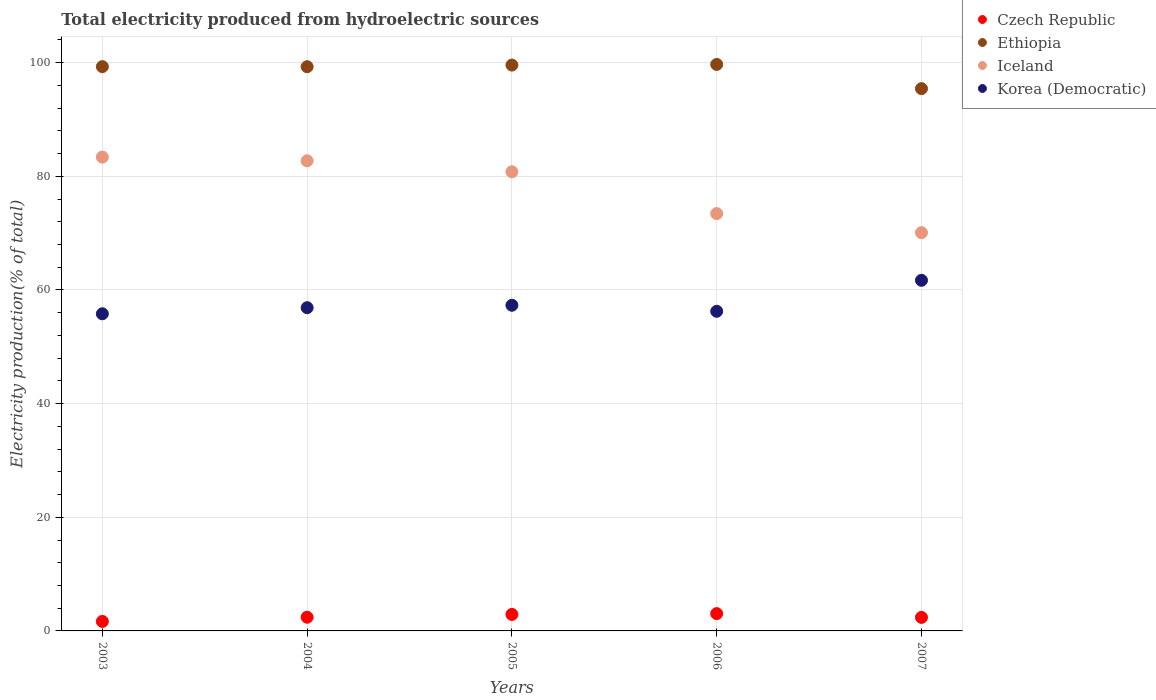How many different coloured dotlines are there?
Give a very brief answer. 4. What is the total electricity produced in Korea (Democratic) in 2003?
Your answer should be compact. 55.81. Across all years, what is the maximum total electricity produced in Czech Republic?
Offer a very short reply. 3.05. Across all years, what is the minimum total electricity produced in Iceland?
Ensure brevity in your answer.  70.08. In which year was the total electricity produced in Iceland maximum?
Offer a terse response. 2003. What is the total total electricity produced in Czech Republic in the graph?
Offer a terse response. 12.41. What is the difference between the total electricity produced in Ethiopia in 2003 and that in 2004?
Your answer should be very brief. 0.01. What is the difference between the total electricity produced in Ethiopia in 2006 and the total electricity produced in Czech Republic in 2007?
Your response must be concise. 97.31. What is the average total electricity produced in Iceland per year?
Provide a short and direct response. 78.09. In the year 2005, what is the difference between the total electricity produced in Iceland and total electricity produced in Korea (Democratic)?
Offer a very short reply. 23.5. What is the ratio of the total electricity produced in Korea (Democratic) in 2005 to that in 2007?
Offer a terse response. 0.93. What is the difference between the highest and the second highest total electricity produced in Iceland?
Give a very brief answer. 0.66. What is the difference between the highest and the lowest total electricity produced in Czech Republic?
Offer a terse response. 1.38. Is it the case that in every year, the sum of the total electricity produced in Ethiopia and total electricity produced in Korea (Democratic)  is greater than the total electricity produced in Czech Republic?
Your answer should be compact. Yes. Is the total electricity produced in Korea (Democratic) strictly less than the total electricity produced in Czech Republic over the years?
Ensure brevity in your answer.  No. How many dotlines are there?
Provide a succinct answer. 4. How many years are there in the graph?
Ensure brevity in your answer.  5. What is the difference between two consecutive major ticks on the Y-axis?
Provide a short and direct response. 20. Does the graph contain any zero values?
Make the answer very short. No. How many legend labels are there?
Ensure brevity in your answer.  4. How are the legend labels stacked?
Keep it short and to the point. Vertical. What is the title of the graph?
Offer a terse response. Total electricity produced from hydroelectric sources. Does "Macedonia" appear as one of the legend labels in the graph?
Your answer should be very brief. No. What is the Electricity production(% of total) in Czech Republic in 2003?
Give a very brief answer. 1.67. What is the Electricity production(% of total) in Ethiopia in 2003?
Make the answer very short. 99.3. What is the Electricity production(% of total) in Iceland in 2003?
Give a very brief answer. 83.39. What is the Electricity production(% of total) of Korea (Democratic) in 2003?
Your response must be concise. 55.81. What is the Electricity production(% of total) of Czech Republic in 2004?
Give a very brief answer. 2.41. What is the Electricity production(% of total) of Ethiopia in 2004?
Offer a terse response. 99.29. What is the Electricity production(% of total) in Iceland in 2004?
Your answer should be very brief. 82.73. What is the Electricity production(% of total) of Korea (Democratic) in 2004?
Provide a succinct answer. 56.89. What is the Electricity production(% of total) of Czech Republic in 2005?
Offer a very short reply. 2.9. What is the Electricity production(% of total) of Ethiopia in 2005?
Provide a short and direct response. 99.58. What is the Electricity production(% of total) of Iceland in 2005?
Keep it short and to the point. 80.81. What is the Electricity production(% of total) in Korea (Democratic) in 2005?
Keep it short and to the point. 57.31. What is the Electricity production(% of total) in Czech Republic in 2006?
Provide a short and direct response. 3.05. What is the Electricity production(% of total) in Ethiopia in 2006?
Offer a very short reply. 99.69. What is the Electricity production(% of total) in Iceland in 2006?
Your answer should be compact. 73.44. What is the Electricity production(% of total) in Korea (Democratic) in 2006?
Provide a succinct answer. 56.25. What is the Electricity production(% of total) of Czech Republic in 2007?
Provide a short and direct response. 2.38. What is the Electricity production(% of total) in Ethiopia in 2007?
Provide a short and direct response. 95.43. What is the Electricity production(% of total) in Iceland in 2007?
Your answer should be compact. 70.08. What is the Electricity production(% of total) in Korea (Democratic) in 2007?
Provide a short and direct response. 61.7. Across all years, what is the maximum Electricity production(% of total) of Czech Republic?
Offer a terse response. 3.05. Across all years, what is the maximum Electricity production(% of total) in Ethiopia?
Provide a succinct answer. 99.69. Across all years, what is the maximum Electricity production(% of total) in Iceland?
Provide a short and direct response. 83.39. Across all years, what is the maximum Electricity production(% of total) in Korea (Democratic)?
Your answer should be very brief. 61.7. Across all years, what is the minimum Electricity production(% of total) in Czech Republic?
Ensure brevity in your answer.  1.67. Across all years, what is the minimum Electricity production(% of total) of Ethiopia?
Offer a very short reply. 95.43. Across all years, what is the minimum Electricity production(% of total) in Iceland?
Your response must be concise. 70.08. Across all years, what is the minimum Electricity production(% of total) in Korea (Democratic)?
Provide a succinct answer. 55.81. What is the total Electricity production(% of total) in Czech Republic in the graph?
Your answer should be very brief. 12.41. What is the total Electricity production(% of total) of Ethiopia in the graph?
Offer a terse response. 493.3. What is the total Electricity production(% of total) of Iceland in the graph?
Your answer should be very brief. 390.46. What is the total Electricity production(% of total) of Korea (Democratic) in the graph?
Provide a succinct answer. 287.96. What is the difference between the Electricity production(% of total) in Czech Republic in 2003 and that in 2004?
Ensure brevity in your answer.  -0.74. What is the difference between the Electricity production(% of total) in Ethiopia in 2003 and that in 2004?
Offer a terse response. 0.01. What is the difference between the Electricity production(% of total) of Iceland in 2003 and that in 2004?
Your answer should be very brief. 0.66. What is the difference between the Electricity production(% of total) of Korea (Democratic) in 2003 and that in 2004?
Your answer should be compact. -1.07. What is the difference between the Electricity production(% of total) of Czech Republic in 2003 and that in 2005?
Your answer should be compact. -1.23. What is the difference between the Electricity production(% of total) of Ethiopia in 2003 and that in 2005?
Give a very brief answer. -0.28. What is the difference between the Electricity production(% of total) of Iceland in 2003 and that in 2005?
Your response must be concise. 2.58. What is the difference between the Electricity production(% of total) in Korea (Democratic) in 2003 and that in 2005?
Your answer should be compact. -1.5. What is the difference between the Electricity production(% of total) in Czech Republic in 2003 and that in 2006?
Your response must be concise. -1.38. What is the difference between the Electricity production(% of total) in Ethiopia in 2003 and that in 2006?
Provide a short and direct response. -0.39. What is the difference between the Electricity production(% of total) of Iceland in 2003 and that in 2006?
Your answer should be very brief. 9.94. What is the difference between the Electricity production(% of total) in Korea (Democratic) in 2003 and that in 2006?
Keep it short and to the point. -0.44. What is the difference between the Electricity production(% of total) in Czech Republic in 2003 and that in 2007?
Keep it short and to the point. -0.71. What is the difference between the Electricity production(% of total) in Ethiopia in 2003 and that in 2007?
Your answer should be compact. 3.87. What is the difference between the Electricity production(% of total) in Iceland in 2003 and that in 2007?
Ensure brevity in your answer.  13.3. What is the difference between the Electricity production(% of total) in Korea (Democratic) in 2003 and that in 2007?
Your answer should be very brief. -5.89. What is the difference between the Electricity production(% of total) of Czech Republic in 2004 and that in 2005?
Ensure brevity in your answer.  -0.5. What is the difference between the Electricity production(% of total) of Ethiopia in 2004 and that in 2005?
Your answer should be compact. -0.29. What is the difference between the Electricity production(% of total) of Iceland in 2004 and that in 2005?
Your response must be concise. 1.92. What is the difference between the Electricity production(% of total) in Korea (Democratic) in 2004 and that in 2005?
Ensure brevity in your answer.  -0.43. What is the difference between the Electricity production(% of total) in Czech Republic in 2004 and that in 2006?
Your answer should be very brief. -0.64. What is the difference between the Electricity production(% of total) in Ethiopia in 2004 and that in 2006?
Provide a succinct answer. -0.4. What is the difference between the Electricity production(% of total) of Iceland in 2004 and that in 2006?
Offer a terse response. 9.29. What is the difference between the Electricity production(% of total) of Korea (Democratic) in 2004 and that in 2006?
Offer a very short reply. 0.64. What is the difference between the Electricity production(% of total) of Czech Republic in 2004 and that in 2007?
Your response must be concise. 0.03. What is the difference between the Electricity production(% of total) of Ethiopia in 2004 and that in 2007?
Your answer should be very brief. 3.86. What is the difference between the Electricity production(% of total) in Iceland in 2004 and that in 2007?
Offer a terse response. 12.65. What is the difference between the Electricity production(% of total) in Korea (Democratic) in 2004 and that in 2007?
Make the answer very short. -4.82. What is the difference between the Electricity production(% of total) in Czech Republic in 2005 and that in 2006?
Make the answer very short. -0.14. What is the difference between the Electricity production(% of total) in Ethiopia in 2005 and that in 2006?
Provide a succinct answer. -0.12. What is the difference between the Electricity production(% of total) in Iceland in 2005 and that in 2006?
Your answer should be very brief. 7.36. What is the difference between the Electricity production(% of total) of Korea (Democratic) in 2005 and that in 2006?
Your response must be concise. 1.06. What is the difference between the Electricity production(% of total) of Czech Republic in 2005 and that in 2007?
Keep it short and to the point. 0.52. What is the difference between the Electricity production(% of total) of Ethiopia in 2005 and that in 2007?
Your answer should be very brief. 4.15. What is the difference between the Electricity production(% of total) of Iceland in 2005 and that in 2007?
Your response must be concise. 10.72. What is the difference between the Electricity production(% of total) in Korea (Democratic) in 2005 and that in 2007?
Your answer should be compact. -4.39. What is the difference between the Electricity production(% of total) of Czech Republic in 2006 and that in 2007?
Your response must be concise. 0.67. What is the difference between the Electricity production(% of total) of Ethiopia in 2006 and that in 2007?
Offer a very short reply. 4.26. What is the difference between the Electricity production(% of total) of Iceland in 2006 and that in 2007?
Offer a terse response. 3.36. What is the difference between the Electricity production(% of total) of Korea (Democratic) in 2006 and that in 2007?
Your answer should be compact. -5.45. What is the difference between the Electricity production(% of total) of Czech Republic in 2003 and the Electricity production(% of total) of Ethiopia in 2004?
Ensure brevity in your answer.  -97.62. What is the difference between the Electricity production(% of total) of Czech Republic in 2003 and the Electricity production(% of total) of Iceland in 2004?
Ensure brevity in your answer.  -81.06. What is the difference between the Electricity production(% of total) in Czech Republic in 2003 and the Electricity production(% of total) in Korea (Democratic) in 2004?
Offer a terse response. -55.22. What is the difference between the Electricity production(% of total) in Ethiopia in 2003 and the Electricity production(% of total) in Iceland in 2004?
Provide a succinct answer. 16.57. What is the difference between the Electricity production(% of total) in Ethiopia in 2003 and the Electricity production(% of total) in Korea (Democratic) in 2004?
Make the answer very short. 42.42. What is the difference between the Electricity production(% of total) in Iceland in 2003 and the Electricity production(% of total) in Korea (Democratic) in 2004?
Your answer should be compact. 26.5. What is the difference between the Electricity production(% of total) of Czech Republic in 2003 and the Electricity production(% of total) of Ethiopia in 2005?
Provide a succinct answer. -97.91. What is the difference between the Electricity production(% of total) in Czech Republic in 2003 and the Electricity production(% of total) in Iceland in 2005?
Make the answer very short. -79.14. What is the difference between the Electricity production(% of total) in Czech Republic in 2003 and the Electricity production(% of total) in Korea (Democratic) in 2005?
Provide a short and direct response. -55.64. What is the difference between the Electricity production(% of total) of Ethiopia in 2003 and the Electricity production(% of total) of Iceland in 2005?
Keep it short and to the point. 18.49. What is the difference between the Electricity production(% of total) of Ethiopia in 2003 and the Electricity production(% of total) of Korea (Democratic) in 2005?
Your answer should be compact. 41.99. What is the difference between the Electricity production(% of total) of Iceland in 2003 and the Electricity production(% of total) of Korea (Democratic) in 2005?
Your answer should be very brief. 26.08. What is the difference between the Electricity production(% of total) in Czech Republic in 2003 and the Electricity production(% of total) in Ethiopia in 2006?
Ensure brevity in your answer.  -98.02. What is the difference between the Electricity production(% of total) of Czech Republic in 2003 and the Electricity production(% of total) of Iceland in 2006?
Keep it short and to the point. -71.77. What is the difference between the Electricity production(% of total) in Czech Republic in 2003 and the Electricity production(% of total) in Korea (Democratic) in 2006?
Your response must be concise. -54.58. What is the difference between the Electricity production(% of total) in Ethiopia in 2003 and the Electricity production(% of total) in Iceland in 2006?
Ensure brevity in your answer.  25.86. What is the difference between the Electricity production(% of total) of Ethiopia in 2003 and the Electricity production(% of total) of Korea (Democratic) in 2006?
Provide a short and direct response. 43.05. What is the difference between the Electricity production(% of total) of Iceland in 2003 and the Electricity production(% of total) of Korea (Democratic) in 2006?
Keep it short and to the point. 27.14. What is the difference between the Electricity production(% of total) in Czech Republic in 2003 and the Electricity production(% of total) in Ethiopia in 2007?
Offer a very short reply. -93.76. What is the difference between the Electricity production(% of total) of Czech Republic in 2003 and the Electricity production(% of total) of Iceland in 2007?
Offer a terse response. -68.41. What is the difference between the Electricity production(% of total) of Czech Republic in 2003 and the Electricity production(% of total) of Korea (Democratic) in 2007?
Give a very brief answer. -60.03. What is the difference between the Electricity production(% of total) in Ethiopia in 2003 and the Electricity production(% of total) in Iceland in 2007?
Offer a terse response. 29.22. What is the difference between the Electricity production(% of total) of Ethiopia in 2003 and the Electricity production(% of total) of Korea (Democratic) in 2007?
Your answer should be compact. 37.6. What is the difference between the Electricity production(% of total) in Iceland in 2003 and the Electricity production(% of total) in Korea (Democratic) in 2007?
Offer a terse response. 21.69. What is the difference between the Electricity production(% of total) in Czech Republic in 2004 and the Electricity production(% of total) in Ethiopia in 2005?
Make the answer very short. -97.17. What is the difference between the Electricity production(% of total) in Czech Republic in 2004 and the Electricity production(% of total) in Iceland in 2005?
Give a very brief answer. -78.4. What is the difference between the Electricity production(% of total) in Czech Republic in 2004 and the Electricity production(% of total) in Korea (Democratic) in 2005?
Offer a terse response. -54.9. What is the difference between the Electricity production(% of total) of Ethiopia in 2004 and the Electricity production(% of total) of Iceland in 2005?
Give a very brief answer. 18.48. What is the difference between the Electricity production(% of total) in Ethiopia in 2004 and the Electricity production(% of total) in Korea (Democratic) in 2005?
Offer a terse response. 41.98. What is the difference between the Electricity production(% of total) in Iceland in 2004 and the Electricity production(% of total) in Korea (Democratic) in 2005?
Your response must be concise. 25.42. What is the difference between the Electricity production(% of total) of Czech Republic in 2004 and the Electricity production(% of total) of Ethiopia in 2006?
Ensure brevity in your answer.  -97.28. What is the difference between the Electricity production(% of total) in Czech Republic in 2004 and the Electricity production(% of total) in Iceland in 2006?
Your answer should be compact. -71.03. What is the difference between the Electricity production(% of total) of Czech Republic in 2004 and the Electricity production(% of total) of Korea (Democratic) in 2006?
Your answer should be compact. -53.84. What is the difference between the Electricity production(% of total) of Ethiopia in 2004 and the Electricity production(% of total) of Iceland in 2006?
Make the answer very short. 25.85. What is the difference between the Electricity production(% of total) in Ethiopia in 2004 and the Electricity production(% of total) in Korea (Democratic) in 2006?
Ensure brevity in your answer.  43.04. What is the difference between the Electricity production(% of total) of Iceland in 2004 and the Electricity production(% of total) of Korea (Democratic) in 2006?
Your response must be concise. 26.48. What is the difference between the Electricity production(% of total) in Czech Republic in 2004 and the Electricity production(% of total) in Ethiopia in 2007?
Ensure brevity in your answer.  -93.02. What is the difference between the Electricity production(% of total) in Czech Republic in 2004 and the Electricity production(% of total) in Iceland in 2007?
Provide a short and direct response. -67.67. What is the difference between the Electricity production(% of total) in Czech Republic in 2004 and the Electricity production(% of total) in Korea (Democratic) in 2007?
Make the answer very short. -59.29. What is the difference between the Electricity production(% of total) in Ethiopia in 2004 and the Electricity production(% of total) in Iceland in 2007?
Ensure brevity in your answer.  29.21. What is the difference between the Electricity production(% of total) in Ethiopia in 2004 and the Electricity production(% of total) in Korea (Democratic) in 2007?
Your response must be concise. 37.59. What is the difference between the Electricity production(% of total) of Iceland in 2004 and the Electricity production(% of total) of Korea (Democratic) in 2007?
Offer a very short reply. 21.03. What is the difference between the Electricity production(% of total) in Czech Republic in 2005 and the Electricity production(% of total) in Ethiopia in 2006?
Offer a terse response. -96.79. What is the difference between the Electricity production(% of total) of Czech Republic in 2005 and the Electricity production(% of total) of Iceland in 2006?
Keep it short and to the point. -70.54. What is the difference between the Electricity production(% of total) of Czech Republic in 2005 and the Electricity production(% of total) of Korea (Democratic) in 2006?
Keep it short and to the point. -53.34. What is the difference between the Electricity production(% of total) of Ethiopia in 2005 and the Electricity production(% of total) of Iceland in 2006?
Offer a terse response. 26.13. What is the difference between the Electricity production(% of total) of Ethiopia in 2005 and the Electricity production(% of total) of Korea (Democratic) in 2006?
Your answer should be compact. 43.33. What is the difference between the Electricity production(% of total) of Iceland in 2005 and the Electricity production(% of total) of Korea (Democratic) in 2006?
Ensure brevity in your answer.  24.56. What is the difference between the Electricity production(% of total) in Czech Republic in 2005 and the Electricity production(% of total) in Ethiopia in 2007?
Keep it short and to the point. -92.53. What is the difference between the Electricity production(% of total) of Czech Republic in 2005 and the Electricity production(% of total) of Iceland in 2007?
Provide a succinct answer. -67.18. What is the difference between the Electricity production(% of total) of Czech Republic in 2005 and the Electricity production(% of total) of Korea (Democratic) in 2007?
Your answer should be very brief. -58.8. What is the difference between the Electricity production(% of total) of Ethiopia in 2005 and the Electricity production(% of total) of Iceland in 2007?
Offer a terse response. 29.49. What is the difference between the Electricity production(% of total) of Ethiopia in 2005 and the Electricity production(% of total) of Korea (Democratic) in 2007?
Make the answer very short. 37.88. What is the difference between the Electricity production(% of total) in Iceland in 2005 and the Electricity production(% of total) in Korea (Democratic) in 2007?
Provide a succinct answer. 19.11. What is the difference between the Electricity production(% of total) of Czech Republic in 2006 and the Electricity production(% of total) of Ethiopia in 2007?
Provide a short and direct response. -92.38. What is the difference between the Electricity production(% of total) of Czech Republic in 2006 and the Electricity production(% of total) of Iceland in 2007?
Make the answer very short. -67.04. What is the difference between the Electricity production(% of total) in Czech Republic in 2006 and the Electricity production(% of total) in Korea (Democratic) in 2007?
Give a very brief answer. -58.65. What is the difference between the Electricity production(% of total) of Ethiopia in 2006 and the Electricity production(% of total) of Iceland in 2007?
Ensure brevity in your answer.  29.61. What is the difference between the Electricity production(% of total) of Ethiopia in 2006 and the Electricity production(% of total) of Korea (Democratic) in 2007?
Your answer should be very brief. 37.99. What is the difference between the Electricity production(% of total) in Iceland in 2006 and the Electricity production(% of total) in Korea (Democratic) in 2007?
Your answer should be compact. 11.74. What is the average Electricity production(% of total) of Czech Republic per year?
Keep it short and to the point. 2.48. What is the average Electricity production(% of total) of Ethiopia per year?
Offer a terse response. 98.66. What is the average Electricity production(% of total) of Iceland per year?
Offer a very short reply. 78.09. What is the average Electricity production(% of total) in Korea (Democratic) per year?
Your response must be concise. 57.59. In the year 2003, what is the difference between the Electricity production(% of total) in Czech Republic and Electricity production(% of total) in Ethiopia?
Your answer should be very brief. -97.63. In the year 2003, what is the difference between the Electricity production(% of total) in Czech Republic and Electricity production(% of total) in Iceland?
Make the answer very short. -81.72. In the year 2003, what is the difference between the Electricity production(% of total) in Czech Republic and Electricity production(% of total) in Korea (Democratic)?
Keep it short and to the point. -54.14. In the year 2003, what is the difference between the Electricity production(% of total) in Ethiopia and Electricity production(% of total) in Iceland?
Your answer should be compact. 15.91. In the year 2003, what is the difference between the Electricity production(% of total) in Ethiopia and Electricity production(% of total) in Korea (Democratic)?
Offer a terse response. 43.49. In the year 2003, what is the difference between the Electricity production(% of total) of Iceland and Electricity production(% of total) of Korea (Democratic)?
Provide a short and direct response. 27.58. In the year 2004, what is the difference between the Electricity production(% of total) in Czech Republic and Electricity production(% of total) in Ethiopia?
Give a very brief answer. -96.88. In the year 2004, what is the difference between the Electricity production(% of total) of Czech Republic and Electricity production(% of total) of Iceland?
Provide a short and direct response. -80.32. In the year 2004, what is the difference between the Electricity production(% of total) in Czech Republic and Electricity production(% of total) in Korea (Democratic)?
Offer a very short reply. -54.48. In the year 2004, what is the difference between the Electricity production(% of total) in Ethiopia and Electricity production(% of total) in Iceland?
Your answer should be compact. 16.56. In the year 2004, what is the difference between the Electricity production(% of total) of Ethiopia and Electricity production(% of total) of Korea (Democratic)?
Provide a short and direct response. 42.41. In the year 2004, what is the difference between the Electricity production(% of total) in Iceland and Electricity production(% of total) in Korea (Democratic)?
Your answer should be compact. 25.85. In the year 2005, what is the difference between the Electricity production(% of total) of Czech Republic and Electricity production(% of total) of Ethiopia?
Keep it short and to the point. -96.67. In the year 2005, what is the difference between the Electricity production(% of total) of Czech Republic and Electricity production(% of total) of Iceland?
Keep it short and to the point. -77.9. In the year 2005, what is the difference between the Electricity production(% of total) of Czech Republic and Electricity production(% of total) of Korea (Democratic)?
Make the answer very short. -54.41. In the year 2005, what is the difference between the Electricity production(% of total) in Ethiopia and Electricity production(% of total) in Iceland?
Provide a succinct answer. 18.77. In the year 2005, what is the difference between the Electricity production(% of total) of Ethiopia and Electricity production(% of total) of Korea (Democratic)?
Give a very brief answer. 42.27. In the year 2005, what is the difference between the Electricity production(% of total) of Iceland and Electricity production(% of total) of Korea (Democratic)?
Keep it short and to the point. 23.5. In the year 2006, what is the difference between the Electricity production(% of total) of Czech Republic and Electricity production(% of total) of Ethiopia?
Keep it short and to the point. -96.65. In the year 2006, what is the difference between the Electricity production(% of total) in Czech Republic and Electricity production(% of total) in Iceland?
Your response must be concise. -70.4. In the year 2006, what is the difference between the Electricity production(% of total) of Czech Republic and Electricity production(% of total) of Korea (Democratic)?
Your answer should be very brief. -53.2. In the year 2006, what is the difference between the Electricity production(% of total) of Ethiopia and Electricity production(% of total) of Iceland?
Provide a short and direct response. 26.25. In the year 2006, what is the difference between the Electricity production(% of total) of Ethiopia and Electricity production(% of total) of Korea (Democratic)?
Make the answer very short. 43.45. In the year 2006, what is the difference between the Electricity production(% of total) of Iceland and Electricity production(% of total) of Korea (Democratic)?
Keep it short and to the point. 17.2. In the year 2007, what is the difference between the Electricity production(% of total) of Czech Republic and Electricity production(% of total) of Ethiopia?
Your answer should be very brief. -93.05. In the year 2007, what is the difference between the Electricity production(% of total) of Czech Republic and Electricity production(% of total) of Iceland?
Offer a very short reply. -67.7. In the year 2007, what is the difference between the Electricity production(% of total) in Czech Republic and Electricity production(% of total) in Korea (Democratic)?
Offer a very short reply. -59.32. In the year 2007, what is the difference between the Electricity production(% of total) of Ethiopia and Electricity production(% of total) of Iceland?
Make the answer very short. 25.35. In the year 2007, what is the difference between the Electricity production(% of total) in Ethiopia and Electricity production(% of total) in Korea (Democratic)?
Your answer should be compact. 33.73. In the year 2007, what is the difference between the Electricity production(% of total) of Iceland and Electricity production(% of total) of Korea (Democratic)?
Your answer should be compact. 8.38. What is the ratio of the Electricity production(% of total) of Czech Republic in 2003 to that in 2004?
Ensure brevity in your answer.  0.69. What is the ratio of the Electricity production(% of total) of Ethiopia in 2003 to that in 2004?
Your answer should be compact. 1. What is the ratio of the Electricity production(% of total) of Iceland in 2003 to that in 2004?
Your answer should be very brief. 1.01. What is the ratio of the Electricity production(% of total) in Korea (Democratic) in 2003 to that in 2004?
Your answer should be compact. 0.98. What is the ratio of the Electricity production(% of total) of Czech Republic in 2003 to that in 2005?
Ensure brevity in your answer.  0.57. What is the ratio of the Electricity production(% of total) of Ethiopia in 2003 to that in 2005?
Keep it short and to the point. 1. What is the ratio of the Electricity production(% of total) in Iceland in 2003 to that in 2005?
Provide a short and direct response. 1.03. What is the ratio of the Electricity production(% of total) of Korea (Democratic) in 2003 to that in 2005?
Provide a short and direct response. 0.97. What is the ratio of the Electricity production(% of total) in Czech Republic in 2003 to that in 2006?
Keep it short and to the point. 0.55. What is the ratio of the Electricity production(% of total) in Ethiopia in 2003 to that in 2006?
Offer a very short reply. 1. What is the ratio of the Electricity production(% of total) of Iceland in 2003 to that in 2006?
Keep it short and to the point. 1.14. What is the ratio of the Electricity production(% of total) in Czech Republic in 2003 to that in 2007?
Provide a succinct answer. 0.7. What is the ratio of the Electricity production(% of total) in Ethiopia in 2003 to that in 2007?
Provide a succinct answer. 1.04. What is the ratio of the Electricity production(% of total) in Iceland in 2003 to that in 2007?
Provide a succinct answer. 1.19. What is the ratio of the Electricity production(% of total) in Korea (Democratic) in 2003 to that in 2007?
Your answer should be compact. 0.9. What is the ratio of the Electricity production(% of total) in Czech Republic in 2004 to that in 2005?
Provide a succinct answer. 0.83. What is the ratio of the Electricity production(% of total) in Iceland in 2004 to that in 2005?
Ensure brevity in your answer.  1.02. What is the ratio of the Electricity production(% of total) of Korea (Democratic) in 2004 to that in 2005?
Your answer should be compact. 0.99. What is the ratio of the Electricity production(% of total) of Czech Republic in 2004 to that in 2006?
Provide a short and direct response. 0.79. What is the ratio of the Electricity production(% of total) of Iceland in 2004 to that in 2006?
Give a very brief answer. 1.13. What is the ratio of the Electricity production(% of total) in Korea (Democratic) in 2004 to that in 2006?
Provide a succinct answer. 1.01. What is the ratio of the Electricity production(% of total) in Czech Republic in 2004 to that in 2007?
Provide a succinct answer. 1.01. What is the ratio of the Electricity production(% of total) in Ethiopia in 2004 to that in 2007?
Provide a short and direct response. 1.04. What is the ratio of the Electricity production(% of total) in Iceland in 2004 to that in 2007?
Give a very brief answer. 1.18. What is the ratio of the Electricity production(% of total) in Korea (Democratic) in 2004 to that in 2007?
Your answer should be very brief. 0.92. What is the ratio of the Electricity production(% of total) of Czech Republic in 2005 to that in 2006?
Your answer should be compact. 0.95. What is the ratio of the Electricity production(% of total) of Iceland in 2005 to that in 2006?
Your answer should be very brief. 1.1. What is the ratio of the Electricity production(% of total) in Korea (Democratic) in 2005 to that in 2006?
Provide a succinct answer. 1.02. What is the ratio of the Electricity production(% of total) in Czech Republic in 2005 to that in 2007?
Give a very brief answer. 1.22. What is the ratio of the Electricity production(% of total) of Ethiopia in 2005 to that in 2007?
Give a very brief answer. 1.04. What is the ratio of the Electricity production(% of total) in Iceland in 2005 to that in 2007?
Provide a succinct answer. 1.15. What is the ratio of the Electricity production(% of total) in Korea (Democratic) in 2005 to that in 2007?
Make the answer very short. 0.93. What is the ratio of the Electricity production(% of total) in Czech Republic in 2006 to that in 2007?
Your answer should be compact. 1.28. What is the ratio of the Electricity production(% of total) of Ethiopia in 2006 to that in 2007?
Keep it short and to the point. 1.04. What is the ratio of the Electricity production(% of total) of Iceland in 2006 to that in 2007?
Provide a short and direct response. 1.05. What is the ratio of the Electricity production(% of total) of Korea (Democratic) in 2006 to that in 2007?
Provide a succinct answer. 0.91. What is the difference between the highest and the second highest Electricity production(% of total) of Czech Republic?
Your answer should be compact. 0.14. What is the difference between the highest and the second highest Electricity production(% of total) in Ethiopia?
Provide a succinct answer. 0.12. What is the difference between the highest and the second highest Electricity production(% of total) of Iceland?
Your answer should be compact. 0.66. What is the difference between the highest and the second highest Electricity production(% of total) of Korea (Democratic)?
Offer a terse response. 4.39. What is the difference between the highest and the lowest Electricity production(% of total) of Czech Republic?
Keep it short and to the point. 1.38. What is the difference between the highest and the lowest Electricity production(% of total) in Ethiopia?
Keep it short and to the point. 4.26. What is the difference between the highest and the lowest Electricity production(% of total) of Iceland?
Make the answer very short. 13.3. What is the difference between the highest and the lowest Electricity production(% of total) in Korea (Democratic)?
Provide a succinct answer. 5.89. 